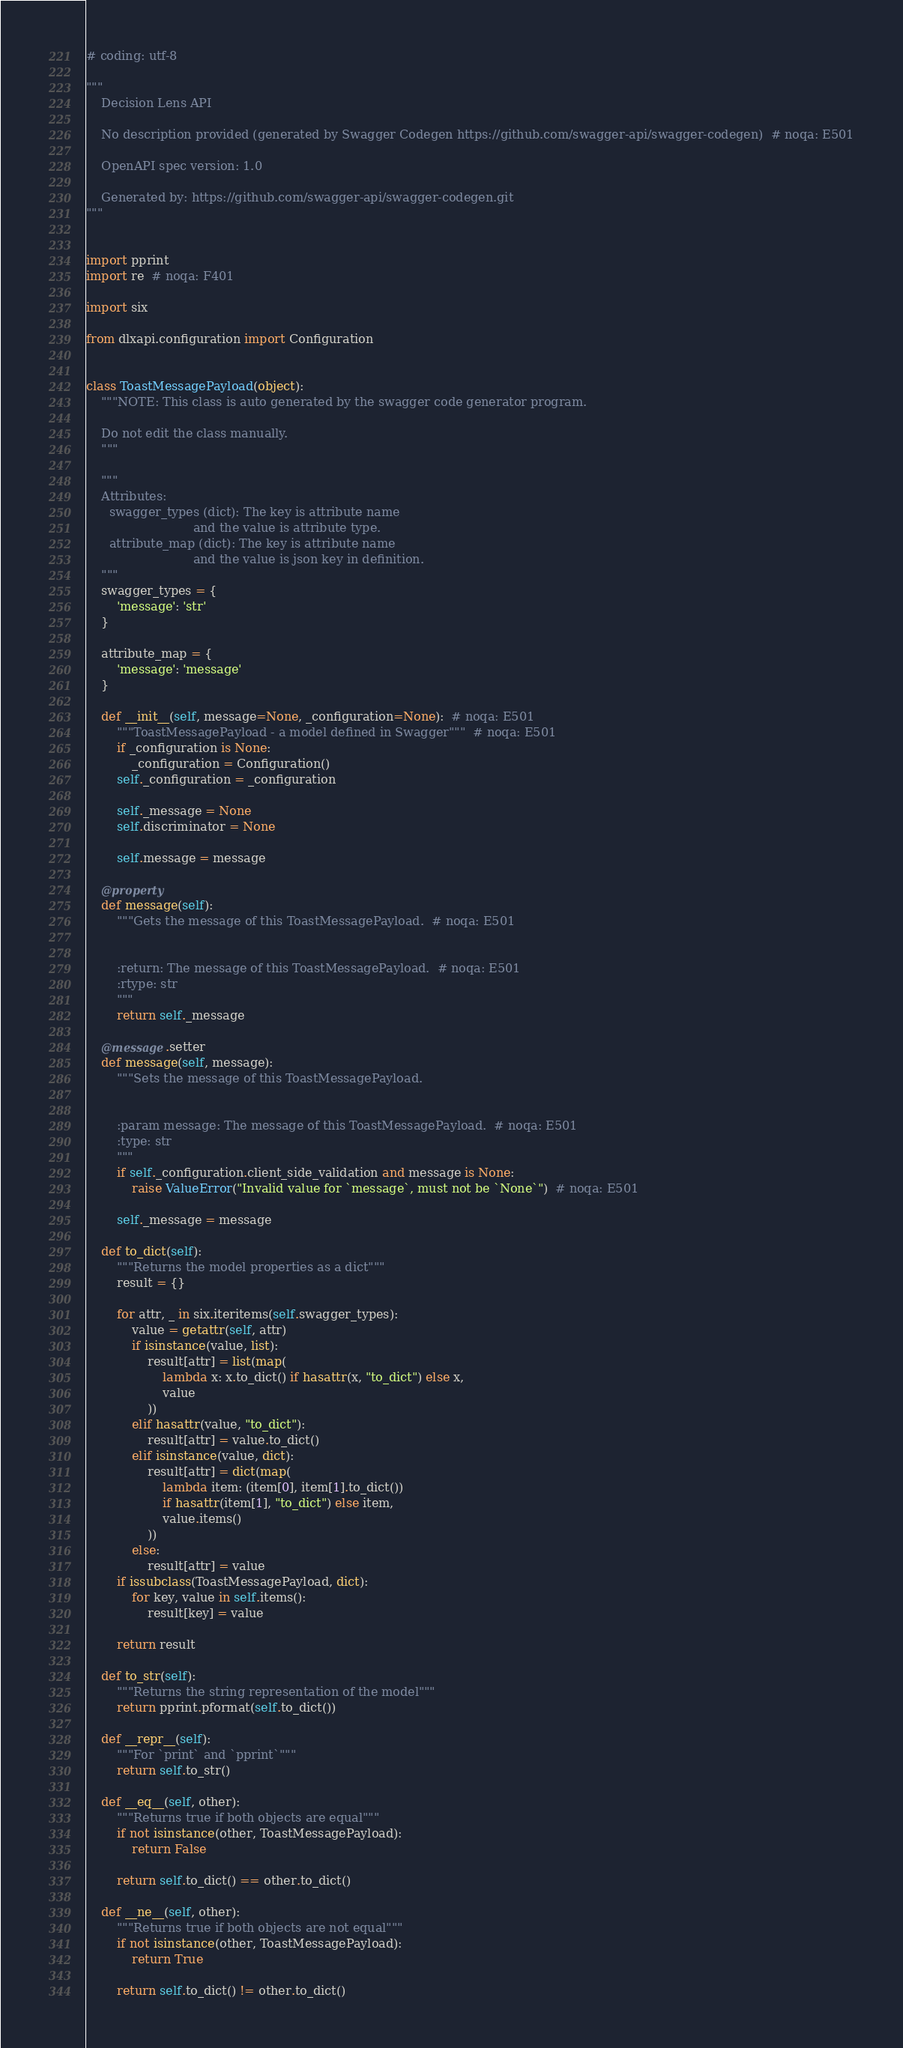<code> <loc_0><loc_0><loc_500><loc_500><_Python_># coding: utf-8

"""
    Decision Lens API

    No description provided (generated by Swagger Codegen https://github.com/swagger-api/swagger-codegen)  # noqa: E501

    OpenAPI spec version: 1.0
    
    Generated by: https://github.com/swagger-api/swagger-codegen.git
"""


import pprint
import re  # noqa: F401

import six

from dlxapi.configuration import Configuration


class ToastMessagePayload(object):
    """NOTE: This class is auto generated by the swagger code generator program.

    Do not edit the class manually.
    """

    """
    Attributes:
      swagger_types (dict): The key is attribute name
                            and the value is attribute type.
      attribute_map (dict): The key is attribute name
                            and the value is json key in definition.
    """
    swagger_types = {
        'message': 'str'
    }

    attribute_map = {
        'message': 'message'
    }

    def __init__(self, message=None, _configuration=None):  # noqa: E501
        """ToastMessagePayload - a model defined in Swagger"""  # noqa: E501
        if _configuration is None:
            _configuration = Configuration()
        self._configuration = _configuration

        self._message = None
        self.discriminator = None

        self.message = message

    @property
    def message(self):
        """Gets the message of this ToastMessagePayload.  # noqa: E501


        :return: The message of this ToastMessagePayload.  # noqa: E501
        :rtype: str
        """
        return self._message

    @message.setter
    def message(self, message):
        """Sets the message of this ToastMessagePayload.


        :param message: The message of this ToastMessagePayload.  # noqa: E501
        :type: str
        """
        if self._configuration.client_side_validation and message is None:
            raise ValueError("Invalid value for `message`, must not be `None`")  # noqa: E501

        self._message = message

    def to_dict(self):
        """Returns the model properties as a dict"""
        result = {}

        for attr, _ in six.iteritems(self.swagger_types):
            value = getattr(self, attr)
            if isinstance(value, list):
                result[attr] = list(map(
                    lambda x: x.to_dict() if hasattr(x, "to_dict") else x,
                    value
                ))
            elif hasattr(value, "to_dict"):
                result[attr] = value.to_dict()
            elif isinstance(value, dict):
                result[attr] = dict(map(
                    lambda item: (item[0], item[1].to_dict())
                    if hasattr(item[1], "to_dict") else item,
                    value.items()
                ))
            else:
                result[attr] = value
        if issubclass(ToastMessagePayload, dict):
            for key, value in self.items():
                result[key] = value

        return result

    def to_str(self):
        """Returns the string representation of the model"""
        return pprint.pformat(self.to_dict())

    def __repr__(self):
        """For `print` and `pprint`"""
        return self.to_str()

    def __eq__(self, other):
        """Returns true if both objects are equal"""
        if not isinstance(other, ToastMessagePayload):
            return False

        return self.to_dict() == other.to_dict()

    def __ne__(self, other):
        """Returns true if both objects are not equal"""
        if not isinstance(other, ToastMessagePayload):
            return True

        return self.to_dict() != other.to_dict()
</code> 